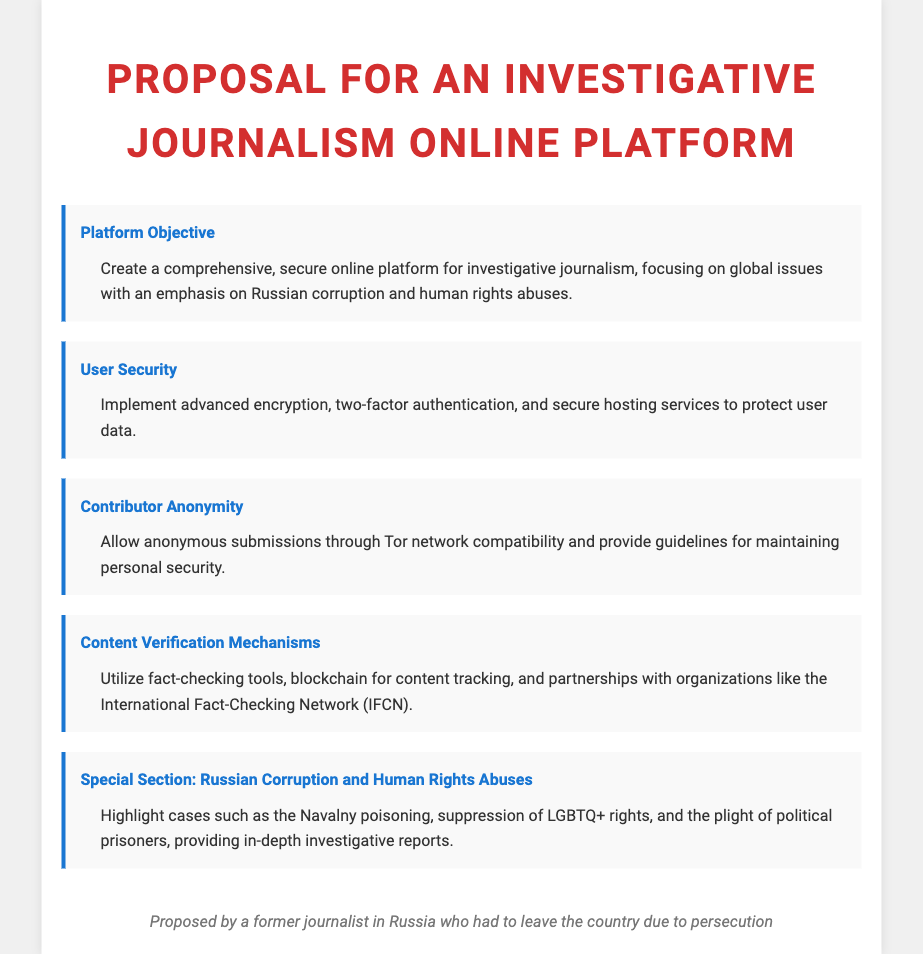What is the main focus of the platform? The main focus of the platform is on global issues, specifically emphasizing Russian corruption and human rights abuses.
Answer: global issues including Russian corruption and human rights abuses What security measure is mentioned for user data protection? The document states that advanced encryption is an implemented security measure to protect user data.
Answer: advanced encryption What allows contributor anonymity? Contributor anonymity is allowed through Tor network compatibility.
Answer: Tor network compatibility Which organization is mentioned for content verification? The International Fact-Checking Network (IFCN) is mentioned for content verification.
Answer: International Fact-Checking Network (IFCN) What high-profile case is highlighted in the proposal? The Navalny poisoning case is highlighted in the proposal.
Answer: Navalny poisoning What is the proposed document's author background? The document is authored by a former journalist from Russia who faced persecution.
Answer: former journalist in Russia who had to leave the country due to persecution What type of platform is being proposed? A secure online platform for investigative journalism is being proposed.
Answer: secure online platform for investigative journalism What specific user feature is discussed besides security? The proposal discusses the feature of contributor anonymity.
Answer: contributor anonymity 